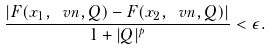<formula> <loc_0><loc_0><loc_500><loc_500>\frac { | F ( x _ { 1 } , \ v n , { Q } ) - F ( x _ { 2 } , \ v n , { Q } ) | } { 1 + | { Q } | ^ { p } } < \epsilon .</formula> 